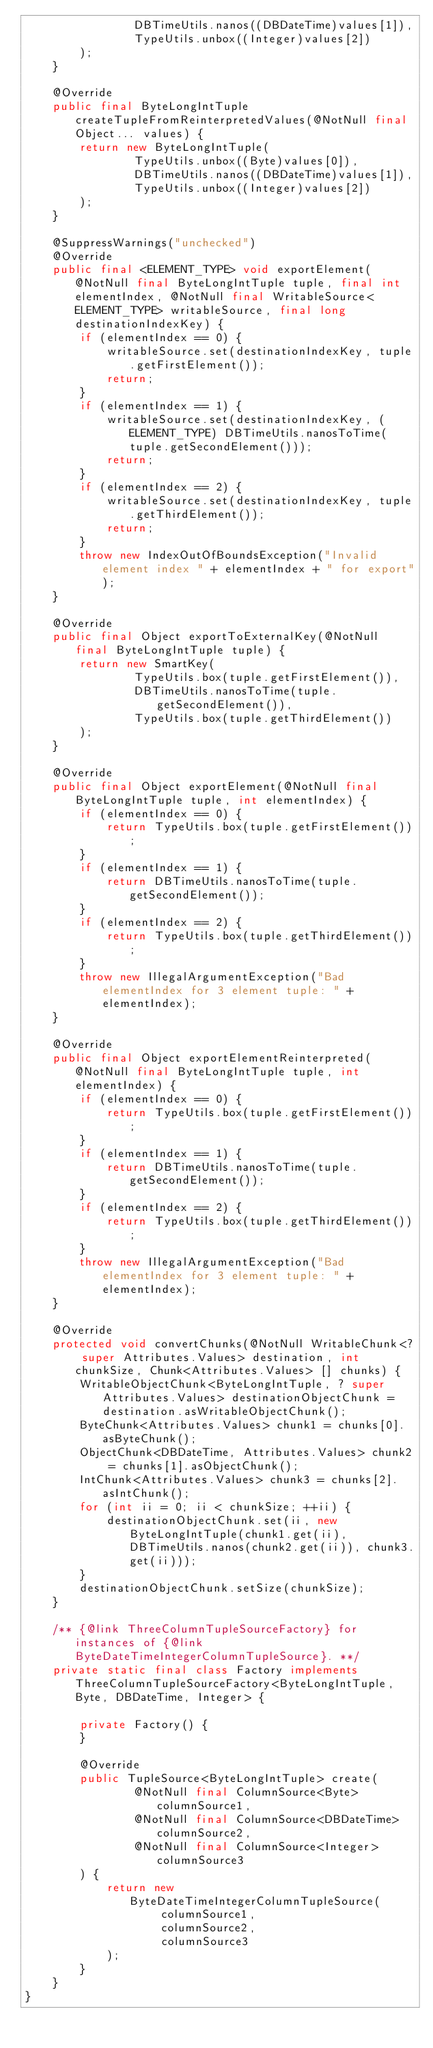<code> <loc_0><loc_0><loc_500><loc_500><_Java_>                DBTimeUtils.nanos((DBDateTime)values[1]),
                TypeUtils.unbox((Integer)values[2])
        );
    }

    @Override
    public final ByteLongIntTuple createTupleFromReinterpretedValues(@NotNull final Object... values) {
        return new ByteLongIntTuple(
                TypeUtils.unbox((Byte)values[0]),
                DBTimeUtils.nanos((DBDateTime)values[1]),
                TypeUtils.unbox((Integer)values[2])
        );
    }

    @SuppressWarnings("unchecked")
    @Override
    public final <ELEMENT_TYPE> void exportElement(@NotNull final ByteLongIntTuple tuple, final int elementIndex, @NotNull final WritableSource<ELEMENT_TYPE> writableSource, final long destinationIndexKey) {
        if (elementIndex == 0) {
            writableSource.set(destinationIndexKey, tuple.getFirstElement());
            return;
        }
        if (elementIndex == 1) {
            writableSource.set(destinationIndexKey, (ELEMENT_TYPE) DBTimeUtils.nanosToTime(tuple.getSecondElement()));
            return;
        }
        if (elementIndex == 2) {
            writableSource.set(destinationIndexKey, tuple.getThirdElement());
            return;
        }
        throw new IndexOutOfBoundsException("Invalid element index " + elementIndex + " for export");
    }

    @Override
    public final Object exportToExternalKey(@NotNull final ByteLongIntTuple tuple) {
        return new SmartKey(
                TypeUtils.box(tuple.getFirstElement()),
                DBTimeUtils.nanosToTime(tuple.getSecondElement()),
                TypeUtils.box(tuple.getThirdElement())
        );
    }

    @Override
    public final Object exportElement(@NotNull final ByteLongIntTuple tuple, int elementIndex) {
        if (elementIndex == 0) {
            return TypeUtils.box(tuple.getFirstElement());
        }
        if (elementIndex == 1) {
            return DBTimeUtils.nanosToTime(tuple.getSecondElement());
        }
        if (elementIndex == 2) {
            return TypeUtils.box(tuple.getThirdElement());
        }
        throw new IllegalArgumentException("Bad elementIndex for 3 element tuple: " + elementIndex);
    }

    @Override
    public final Object exportElementReinterpreted(@NotNull final ByteLongIntTuple tuple, int elementIndex) {
        if (elementIndex == 0) {
            return TypeUtils.box(tuple.getFirstElement());
        }
        if (elementIndex == 1) {
            return DBTimeUtils.nanosToTime(tuple.getSecondElement());
        }
        if (elementIndex == 2) {
            return TypeUtils.box(tuple.getThirdElement());
        }
        throw new IllegalArgumentException("Bad elementIndex for 3 element tuple: " + elementIndex);
    }

    @Override
    protected void convertChunks(@NotNull WritableChunk<? super Attributes.Values> destination, int chunkSize, Chunk<Attributes.Values> [] chunks) {
        WritableObjectChunk<ByteLongIntTuple, ? super Attributes.Values> destinationObjectChunk = destination.asWritableObjectChunk();
        ByteChunk<Attributes.Values> chunk1 = chunks[0].asByteChunk();
        ObjectChunk<DBDateTime, Attributes.Values> chunk2 = chunks[1].asObjectChunk();
        IntChunk<Attributes.Values> chunk3 = chunks[2].asIntChunk();
        for (int ii = 0; ii < chunkSize; ++ii) {
            destinationObjectChunk.set(ii, new ByteLongIntTuple(chunk1.get(ii), DBTimeUtils.nanos(chunk2.get(ii)), chunk3.get(ii)));
        }
        destinationObjectChunk.setSize(chunkSize);
    }

    /** {@link ThreeColumnTupleSourceFactory} for instances of {@link ByteDateTimeIntegerColumnTupleSource}. **/
    private static final class Factory implements ThreeColumnTupleSourceFactory<ByteLongIntTuple, Byte, DBDateTime, Integer> {

        private Factory() {
        }

        @Override
        public TupleSource<ByteLongIntTuple> create(
                @NotNull final ColumnSource<Byte> columnSource1,
                @NotNull final ColumnSource<DBDateTime> columnSource2,
                @NotNull final ColumnSource<Integer> columnSource3
        ) {
            return new ByteDateTimeIntegerColumnTupleSource(
                    columnSource1,
                    columnSource2,
                    columnSource3
            );
        }
    }
}
</code> 